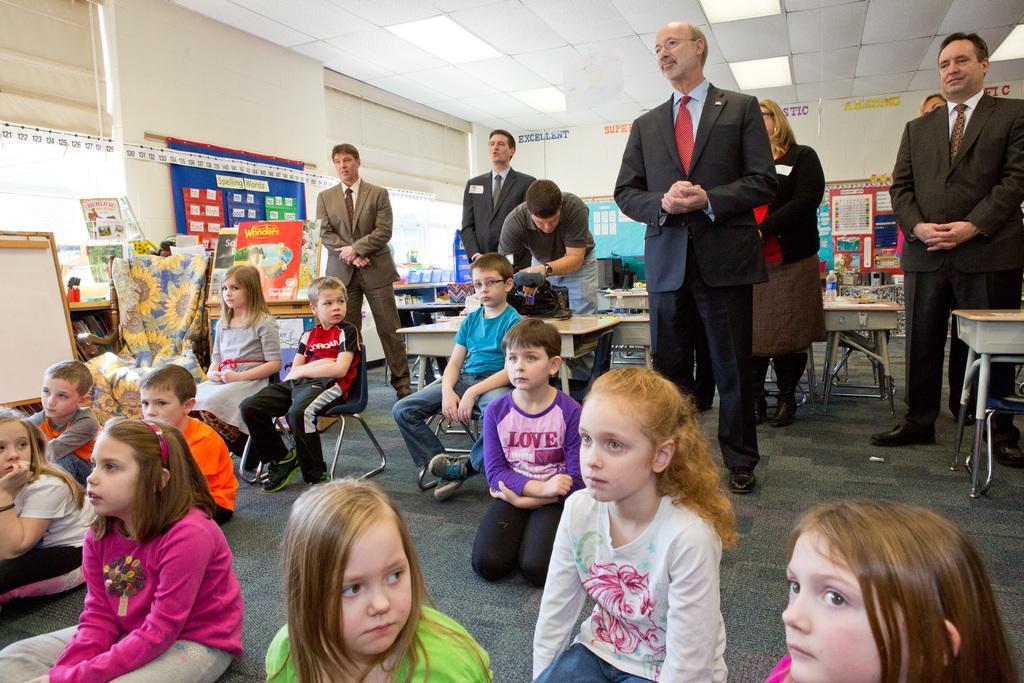Please provide a concise description of this image. In this image we can see there are a few people sitting on the floor, few people standing and few people sitting on the chair. And there are boards attached to the wall. And there are tables, on the table there is the bottle and a few objects. There is the chair with a cloth and at the top there is the ceiling with lights. 